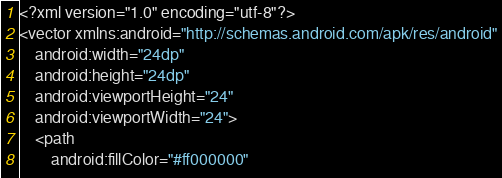Convert code to text. <code><loc_0><loc_0><loc_500><loc_500><_XML_><?xml version="1.0" encoding="utf-8"?>
<vector xmlns:android="http://schemas.android.com/apk/res/android"
    android:width="24dp"
    android:height="24dp"
    android:viewportHeight="24"
    android:viewportWidth="24">
    <path
        android:fillColor="#ff000000"</code> 